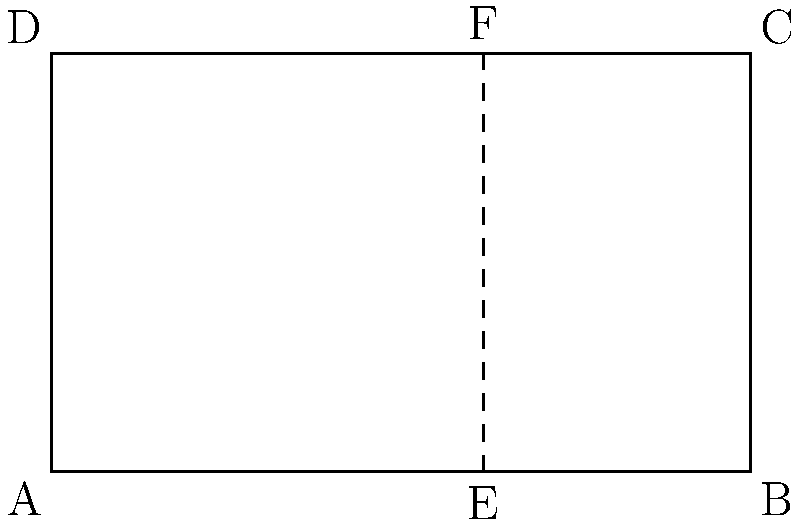A book cover designer is creating a layout based on the golden ratio. The cover is represented by the rectangle ABCD, with dimensions 10 cm × 6 cm. Point E divides the bottom edge AB according to the golden ratio. Calculate the length of AE to two decimal places. To find the length of AE, we'll use the properties of the golden ratio and the given dimensions of the book cover.

Step 1: Recall the golden ratio formula
The golden ratio is approximately 1.618, and it satisfies the equation:
$$(a + b) : a = a : b$$

Step 2: Set up the ratio for the book cover
Let x be the length of AE. Then:
$$10 : x = x : (10 - x)$$

Step 3: Cross multiply
$$10(10 - x) = x^2$$

Step 4: Expand the equation
$$100 - 10x = x^2$$

Step 5: Rearrange to standard quadratic form
$$x^2 + 10x - 100 = 0$$

Step 6: Use the quadratic formula to solve for x
$$x = \frac{-b \pm \sqrt{b^2 - 4ac}}{2a}$$
Where $a = 1$, $b = 10$, and $c = -100$

$$x = \frac{-10 \pm \sqrt{100 + 400}}{2} = \frac{-10 \pm \sqrt{500}}{2}$$

Step 7: Simplify and calculate
$$x = \frac{-10 + \sqrt{500}}{2} \approx 6.18$$ (we discard the negative solution)

Therefore, the length of AE is approximately 6.18 cm.
Answer: 6.18 cm 